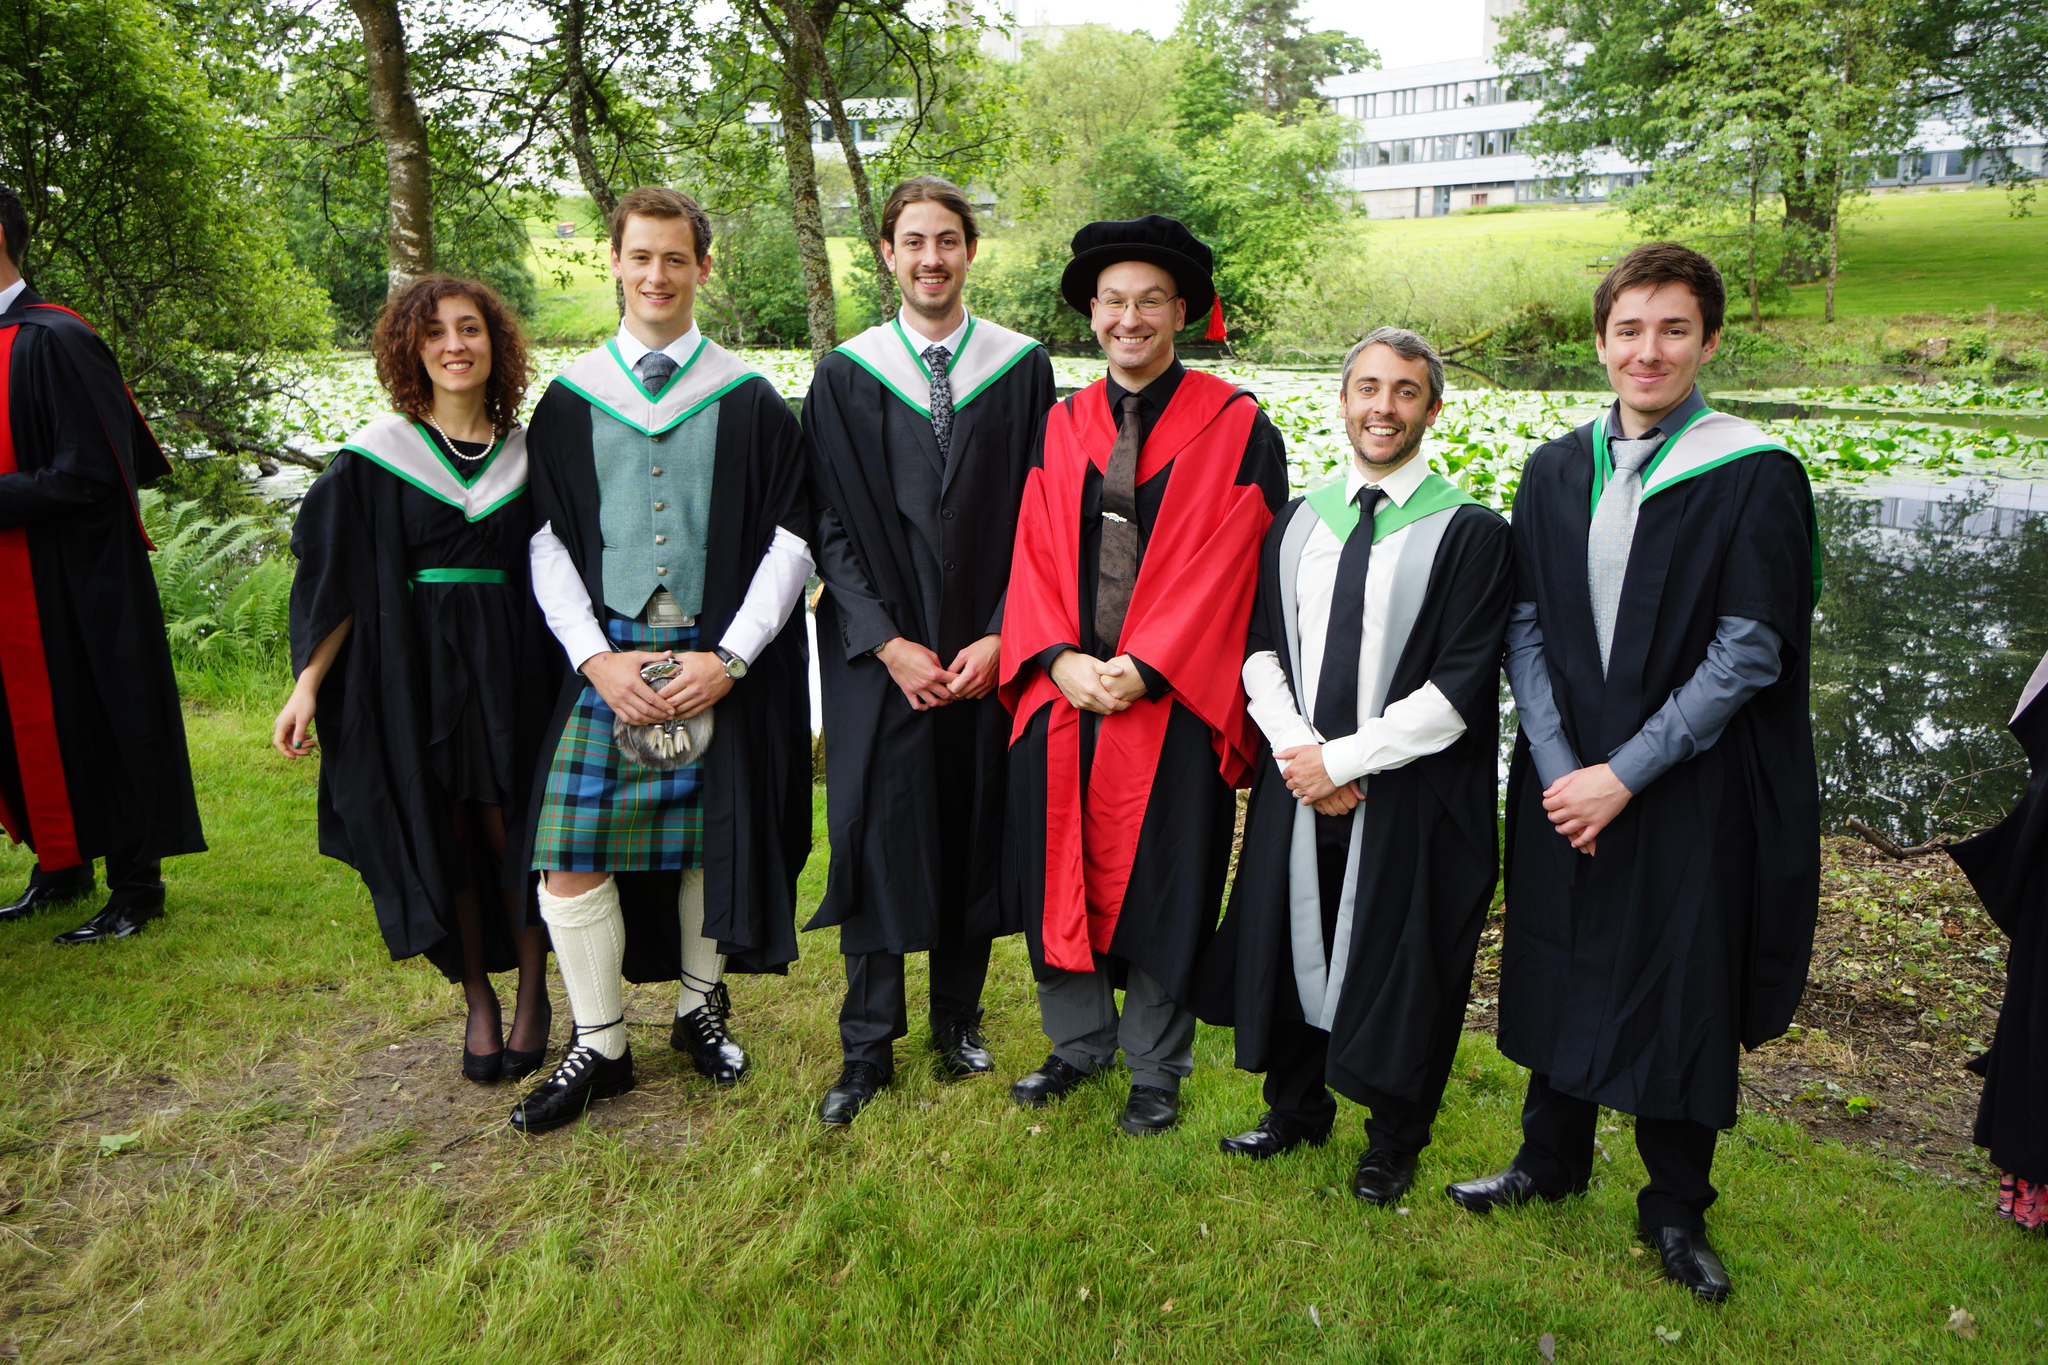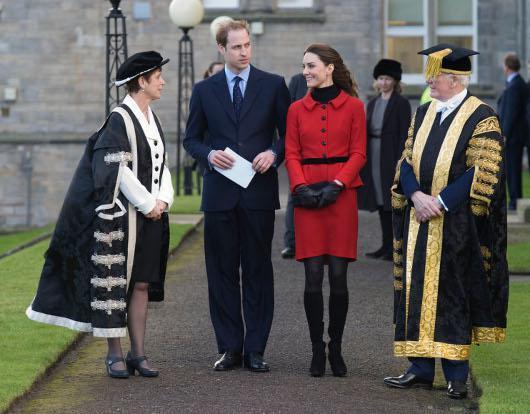The first image is the image on the left, the second image is the image on the right. Given the left and right images, does the statement "Right image shows multiple graduates holding red rolled items, and includes a fellow in a kilt." hold true? Answer yes or no. No. The first image is the image on the left, the second image is the image on the right. Evaluate the accuracy of this statement regarding the images: "In each image, at least one black-robed graduate is holding a diploma in a red tube, while standing in front of a large stone building.". Is it true? Answer yes or no. No. 